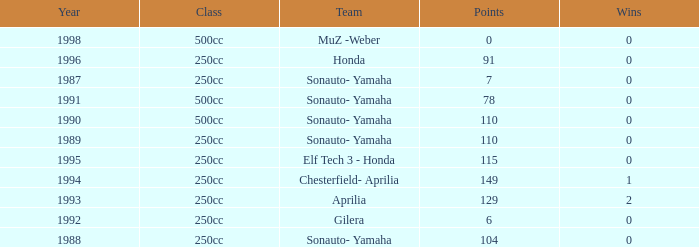Could you help me parse every detail presented in this table? {'header': ['Year', 'Class', 'Team', 'Points', 'Wins'], 'rows': [['1998', '500cc', 'MuZ -Weber', '0', '0'], ['1996', '250cc', 'Honda', '91', '0'], ['1987', '250cc', 'Sonauto- Yamaha', '7', '0'], ['1991', '500cc', 'Sonauto- Yamaha', '78', '0'], ['1990', '500cc', 'Sonauto- Yamaha', '110', '0'], ['1989', '250cc', 'Sonauto- Yamaha', '110', '0'], ['1995', '250cc', 'Elf Tech 3 - Honda', '115', '0'], ['1994', '250cc', 'Chesterfield- Aprilia', '149', '1'], ['1993', '250cc', 'Aprilia', '129', '2'], ['1992', '250cc', 'Gilera', '6', '0'], ['1988', '250cc', 'Sonauto- Yamaha', '104', '0']]} How many wins did the team, which had more than 110 points, have in 1989? None. 